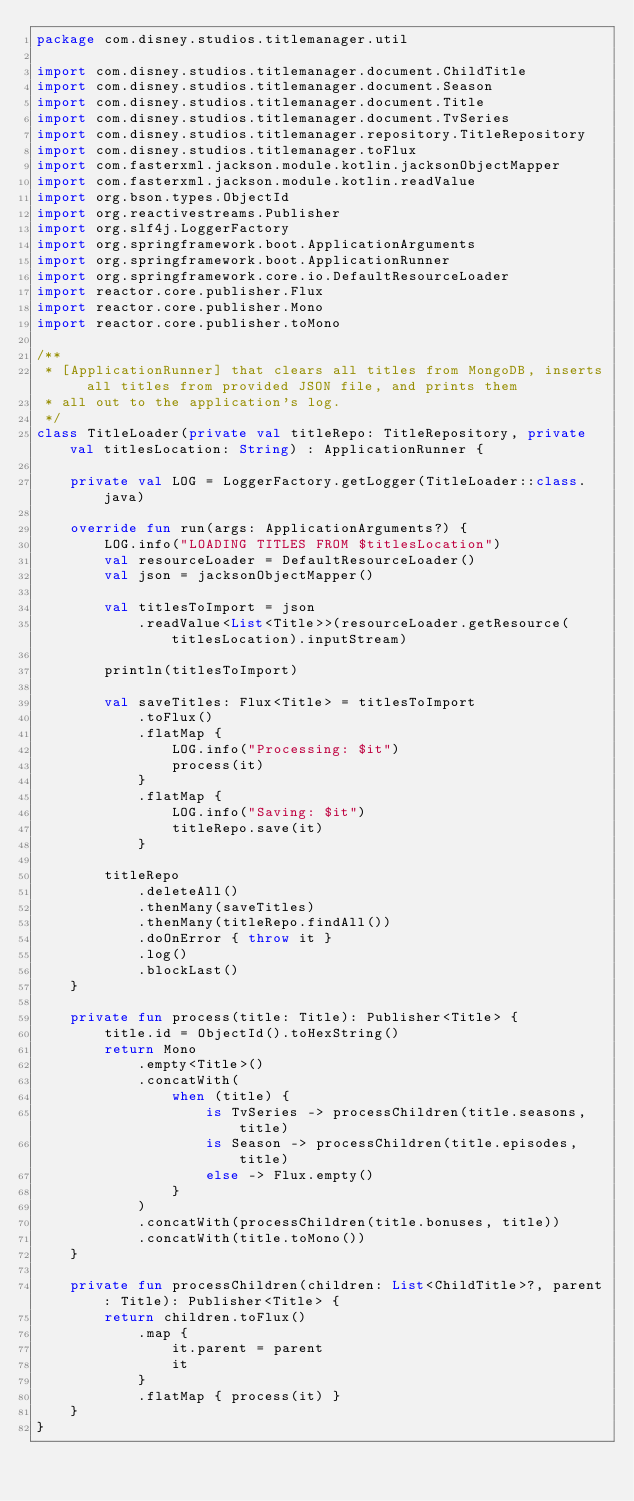<code> <loc_0><loc_0><loc_500><loc_500><_Kotlin_>package com.disney.studios.titlemanager.util

import com.disney.studios.titlemanager.document.ChildTitle
import com.disney.studios.titlemanager.document.Season
import com.disney.studios.titlemanager.document.Title
import com.disney.studios.titlemanager.document.TvSeries
import com.disney.studios.titlemanager.repository.TitleRepository
import com.disney.studios.titlemanager.toFlux
import com.fasterxml.jackson.module.kotlin.jacksonObjectMapper
import com.fasterxml.jackson.module.kotlin.readValue
import org.bson.types.ObjectId
import org.reactivestreams.Publisher
import org.slf4j.LoggerFactory
import org.springframework.boot.ApplicationArguments
import org.springframework.boot.ApplicationRunner
import org.springframework.core.io.DefaultResourceLoader
import reactor.core.publisher.Flux
import reactor.core.publisher.Mono
import reactor.core.publisher.toMono

/**
 * [ApplicationRunner] that clears all titles from MongoDB, inserts all titles from provided JSON file, and prints them
 * all out to the application's log.
 */
class TitleLoader(private val titleRepo: TitleRepository, private val titlesLocation: String) : ApplicationRunner {

    private val LOG = LoggerFactory.getLogger(TitleLoader::class.java)

    override fun run(args: ApplicationArguments?) {
        LOG.info("LOADING TITLES FROM $titlesLocation")
        val resourceLoader = DefaultResourceLoader()
        val json = jacksonObjectMapper()

        val titlesToImport = json
            .readValue<List<Title>>(resourceLoader.getResource(titlesLocation).inputStream)

        println(titlesToImport)

        val saveTitles: Flux<Title> = titlesToImport
            .toFlux()
            .flatMap {
                LOG.info("Processing: $it")
                process(it)
            }
            .flatMap {
                LOG.info("Saving: $it")
                titleRepo.save(it)
            }

        titleRepo
            .deleteAll()
            .thenMany(saveTitles)
            .thenMany(titleRepo.findAll())
            .doOnError { throw it }
            .log()
            .blockLast()
    }

    private fun process(title: Title): Publisher<Title> {
        title.id = ObjectId().toHexString()
        return Mono
            .empty<Title>()
            .concatWith(
                when (title) {
                    is TvSeries -> processChildren(title.seasons, title)
                    is Season -> processChildren(title.episodes, title)
                    else -> Flux.empty()
                }
            )
            .concatWith(processChildren(title.bonuses, title))
            .concatWith(title.toMono())
    }

    private fun processChildren(children: List<ChildTitle>?, parent: Title): Publisher<Title> {
        return children.toFlux()
            .map {
                it.parent = parent
                it
            }
            .flatMap { process(it) }
    }
}</code> 